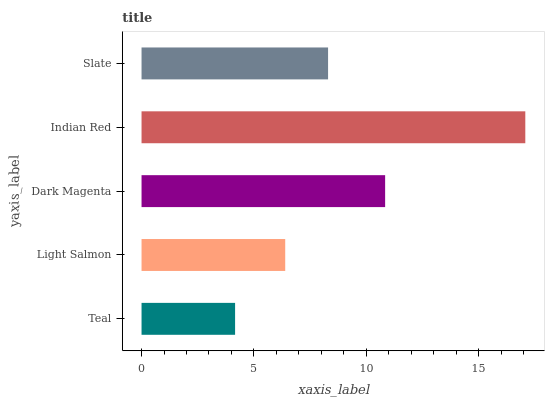Is Teal the minimum?
Answer yes or no. Yes. Is Indian Red the maximum?
Answer yes or no. Yes. Is Light Salmon the minimum?
Answer yes or no. No. Is Light Salmon the maximum?
Answer yes or no. No. Is Light Salmon greater than Teal?
Answer yes or no. Yes. Is Teal less than Light Salmon?
Answer yes or no. Yes. Is Teal greater than Light Salmon?
Answer yes or no. No. Is Light Salmon less than Teal?
Answer yes or no. No. Is Slate the high median?
Answer yes or no. Yes. Is Slate the low median?
Answer yes or no. Yes. Is Dark Magenta the high median?
Answer yes or no. No. Is Light Salmon the low median?
Answer yes or no. No. 